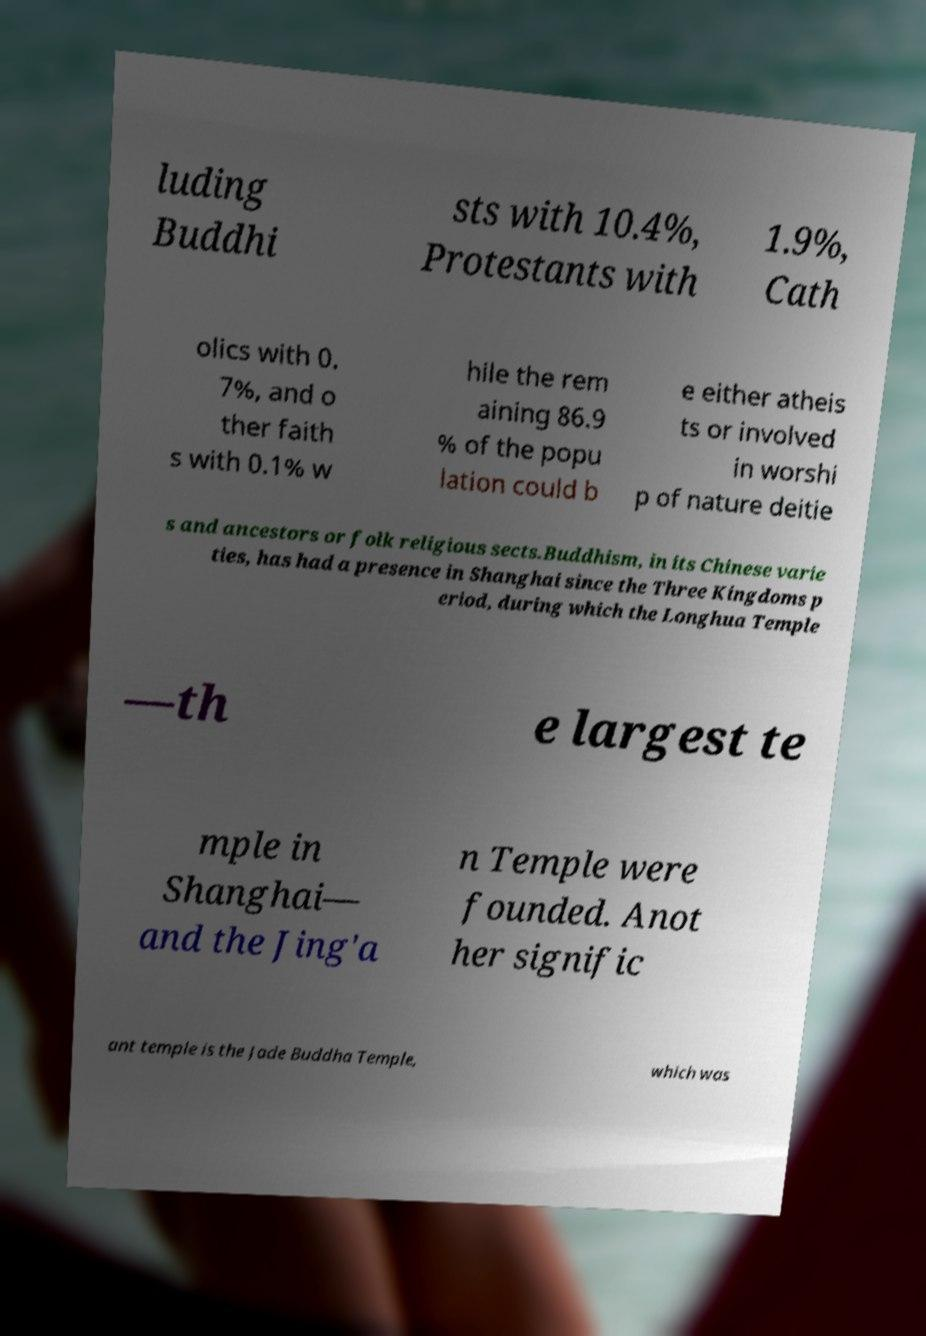Please read and relay the text visible in this image. What does it say? luding Buddhi sts with 10.4%, Protestants with 1.9%, Cath olics with 0. 7%, and o ther faith s with 0.1% w hile the rem aining 86.9 % of the popu lation could b e either atheis ts or involved in worshi p of nature deitie s and ancestors or folk religious sects.Buddhism, in its Chinese varie ties, has had a presence in Shanghai since the Three Kingdoms p eriod, during which the Longhua Temple —th e largest te mple in Shanghai— and the Jing'a n Temple were founded. Anot her signific ant temple is the Jade Buddha Temple, which was 